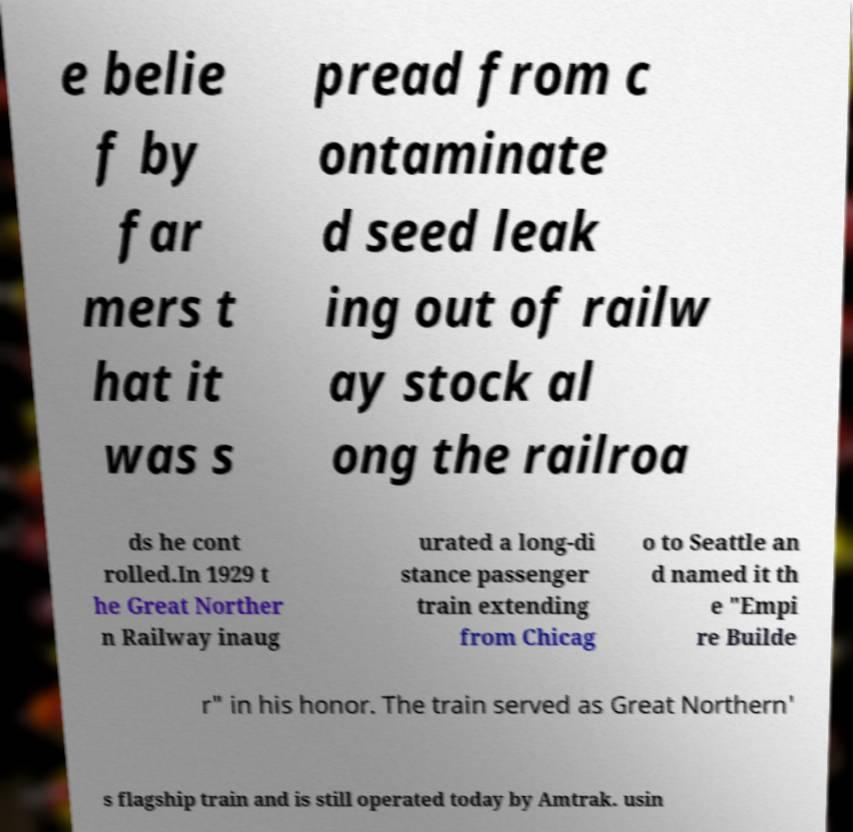Please read and relay the text visible in this image. What does it say? e belie f by far mers t hat it was s pread from c ontaminate d seed leak ing out of railw ay stock al ong the railroa ds he cont rolled.In 1929 t he Great Norther n Railway inaug urated a long-di stance passenger train extending from Chicag o to Seattle an d named it th e "Empi re Builde r" in his honor. The train served as Great Northern' s flagship train and is still operated today by Amtrak. usin 